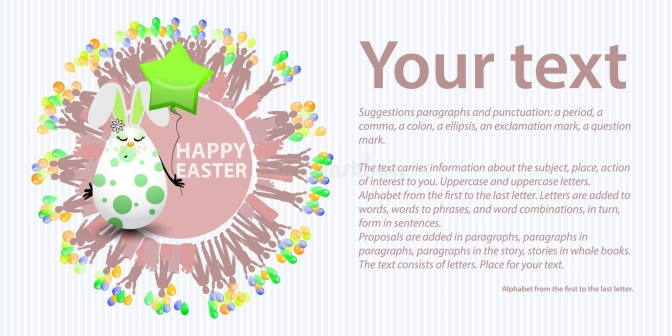Can you describe the main features of this image for me? In the image, there's a delightful and festive scene with a sense of celebration and joy. The backdrop features a light pink background with white polka dots, creating a playful atmosphere. Central to the scene is a whimsical white Easter bunny adorned with cute green and pink spots. The bunny seems to be in the celebratory spirit, holding a green balloon shaped like a star. The backdrop is further animated with colorful confetti pieces surrounding the bunny, adding to the festive mood.

To the right of the bunny, a text box with a gray border and background stands out. This box contains the customizable text "Your text" in white, suggesting that the image can be personalized. The text box is there to provide space for any message the user wishes to include, allowing for a versatile use of the image.

Additionally, behind the bunny, there's a circular text burst stating "HAPPY EASTER," which links directly to the Easter theme. The combination of the bunny, balloon, confetti, and text box creates a lively and inviting composition. This image could be used for a wide variety of occasions, though it does suggest a strong Easter-related theme. 